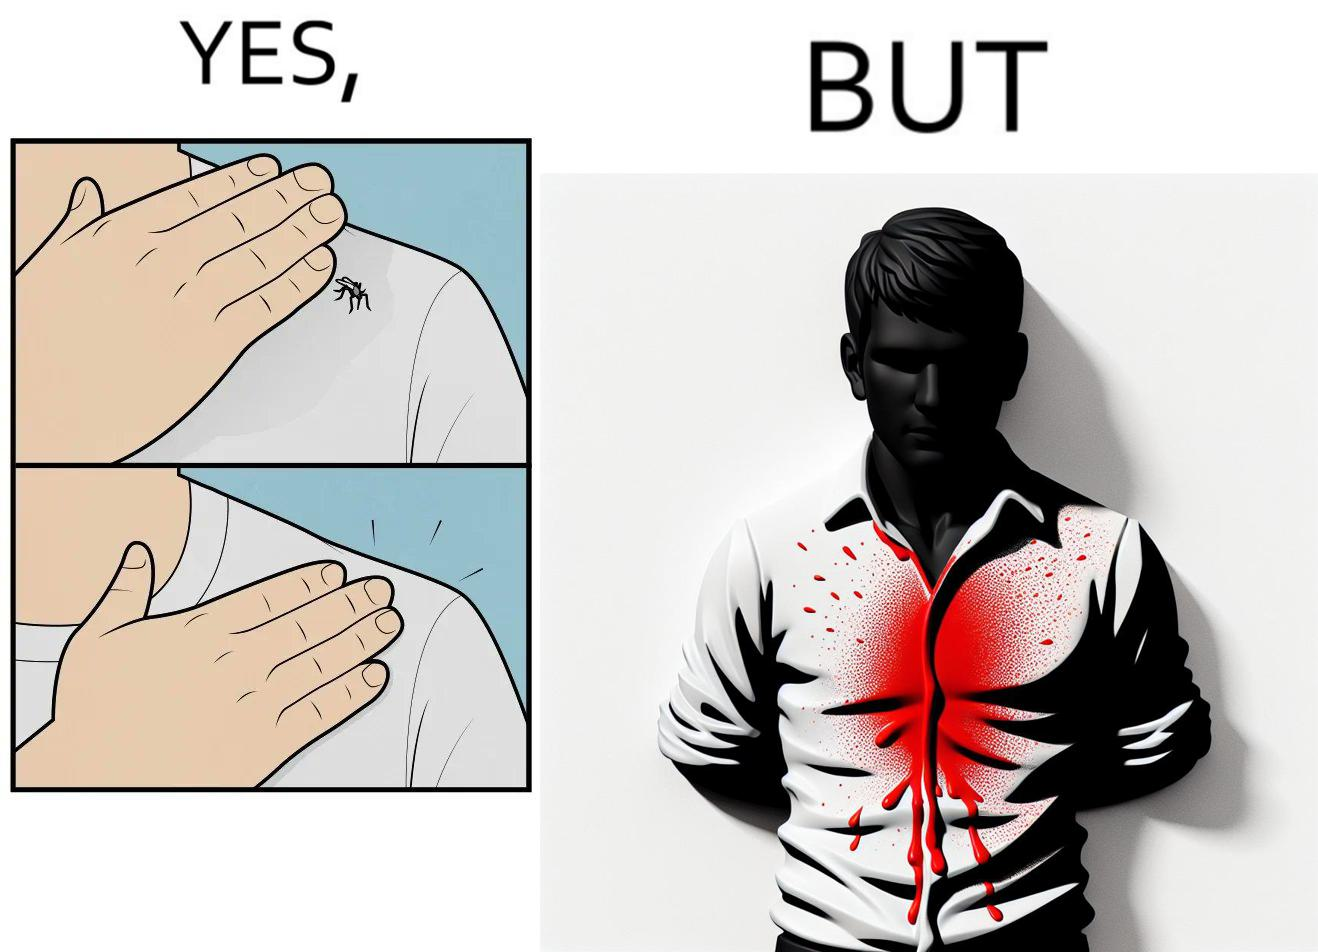Describe what you see in the left and right parts of this image. In the left part of the image: It is a set of two images of a man killing a mosquito by hand. In the right part of the image: It is man with red liquid smeared on his t-shirt 